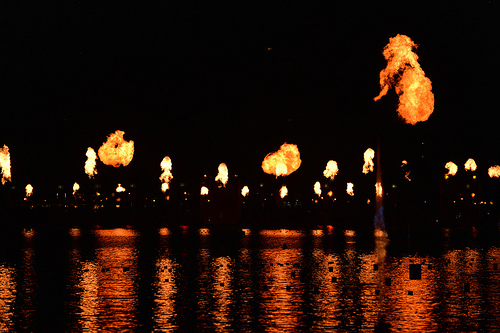<image>
Can you confirm if the fire is on the water? No. The fire is not positioned on the water. They may be near each other, but the fire is not supported by or resting on top of the water. 